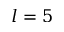Convert formula to latex. <formula><loc_0><loc_0><loc_500><loc_500>l = 5</formula> 